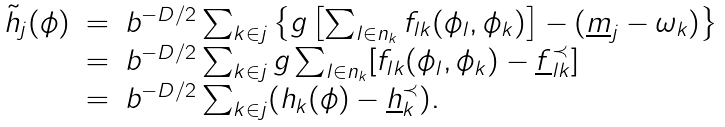<formula> <loc_0><loc_0><loc_500><loc_500>\begin{array} { l l l } \tilde { h } _ { j } ( \phi ) & = & b ^ { - D / 2 } \sum _ { k \in j } \left \{ g \left [ \sum _ { l \in n _ { k } } f _ { l k } ( \phi _ { l } , \phi _ { k } ) \right ] - ( \underline { m } _ { j } - \omega _ { k } ) \right \} \\ & = & b ^ { - D / 2 } \sum _ { k \in j } g \sum _ { l \in n _ { k } } [ f _ { l k } ( \phi _ { l } , \phi _ { k } ) - \underline { f } _ { l k } ^ { \prec } ] \\ & = & b ^ { - D / 2 } \sum _ { k \in j } ( h _ { k } ( \phi ) - \underline { h } _ { k } ^ { \prec } ) . \end{array}</formula> 